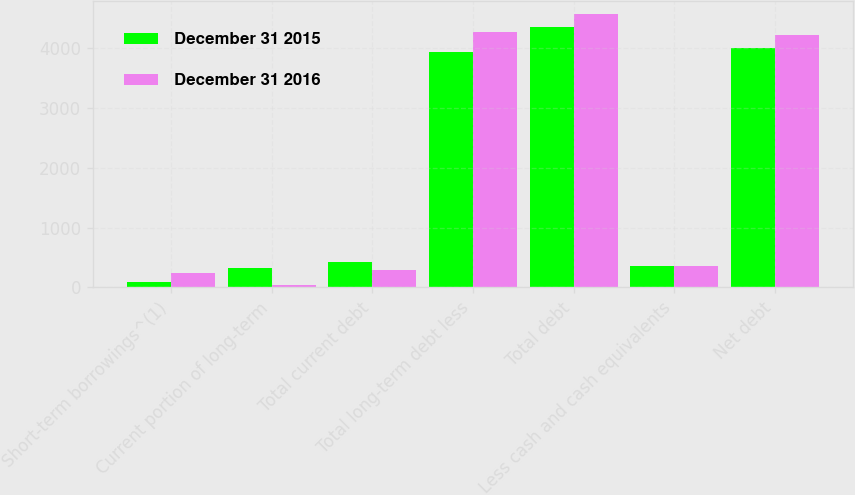<chart> <loc_0><loc_0><loc_500><loc_500><stacked_bar_chart><ecel><fcel>Short-term borrowings^(1)<fcel>Current portion of long-term<fcel>Total current debt<fcel>Total long-term debt less<fcel>Total debt<fcel>Less cash and cash equivalents<fcel>Net debt<nl><fcel>December 31 2015<fcel>92.6<fcel>328.1<fcel>420.7<fcel>3938.3<fcel>4359<fcel>363.7<fcel>3995.3<nl><fcel>December 31 2016<fcel>248.2<fcel>46.6<fcel>294.8<fcel>4266.8<fcel>4561.6<fcel>351.7<fcel>4209.9<nl></chart> 